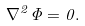<formula> <loc_0><loc_0><loc_500><loc_500>\nabla ^ { 2 } \Phi = 0 .</formula> 